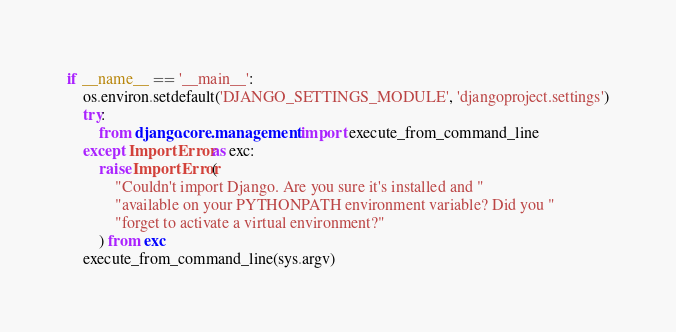<code> <loc_0><loc_0><loc_500><loc_500><_Python_>
if __name__ == '__main__':
    os.environ.setdefault('DJANGO_SETTINGS_MODULE', 'djangoproject.settings')
    try:
        from django.core.management import execute_from_command_line
    except ImportError as exc:
        raise ImportError(
            "Couldn't import Django. Are you sure it's installed and "
            "available on your PYTHONPATH environment variable? Did you "
            "forget to activate a virtual environment?"
        ) from exc
    execute_from_command_line(sys.argv)
</code> 